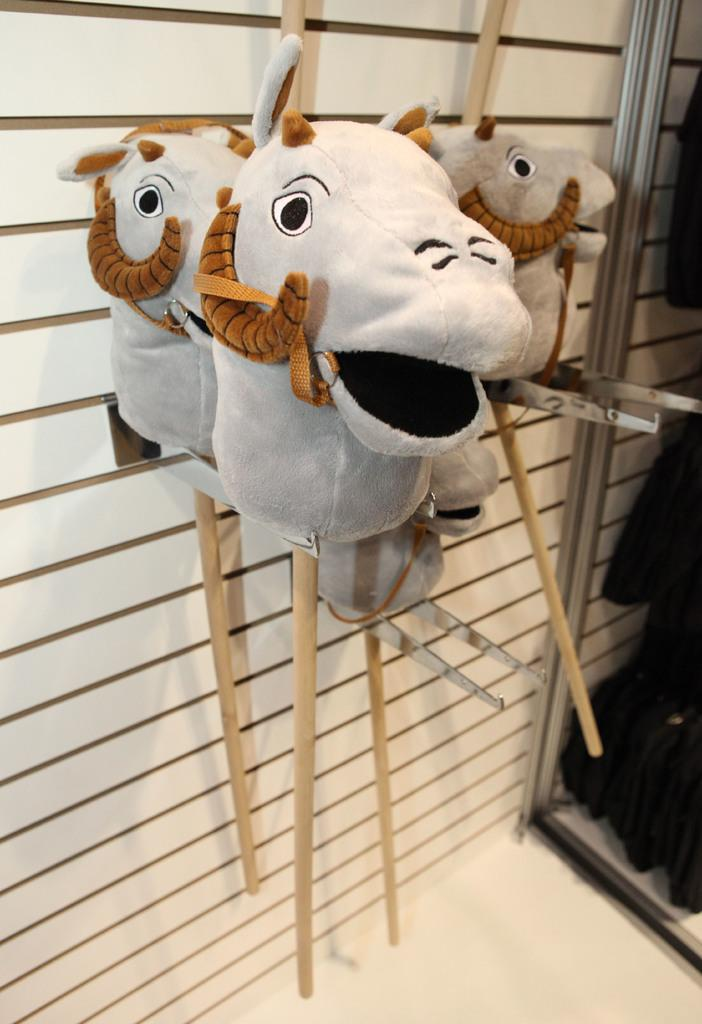What objects are present in the image? There are dolls in the image. What are the dolls holding? The dolls are holding sticks. What can be seen in the background of the image? There is a wall visible in the image. How many cars are parked next to the wall in the image? There are no cars present in the image; it only features dolls holding sticks and a wall in the background. 